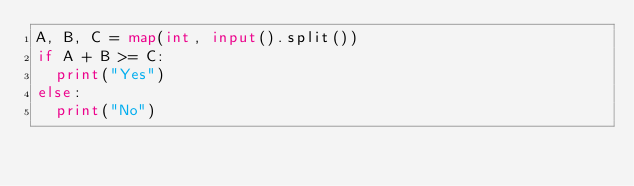Convert code to text. <code><loc_0><loc_0><loc_500><loc_500><_Python_>A, B, C = map(int, input().split())
if A + B >= C:
  print("Yes")
else:
  print("No")</code> 